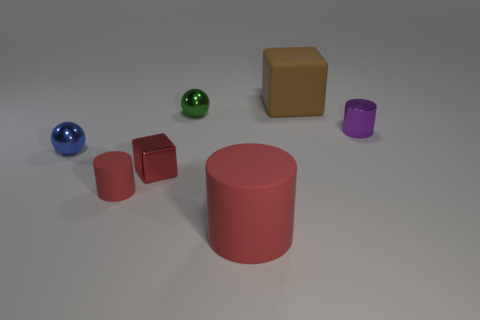Is the number of red cylinders on the right side of the tiny red matte cylinder greater than the number of big brown blocks that are right of the tiny metal cylinder? Upon examining the image, I observe that there are no red cylinders to the right of the tiny red matte cylinder. There are two red cubes, a blue and a green sphere, along with a purple cylinder, but no red cylinders. Therefore, the comparison with the big brown blocks becomes unnecessary as there are no red cylinders to count. As for the big brown blocks, there is only one obvious brown block present in the image, and it is located near the center rather than to the right of any tiny metal cylinder. The answer could very much depend on specific perspectives and definitions within the context of the image provided. 